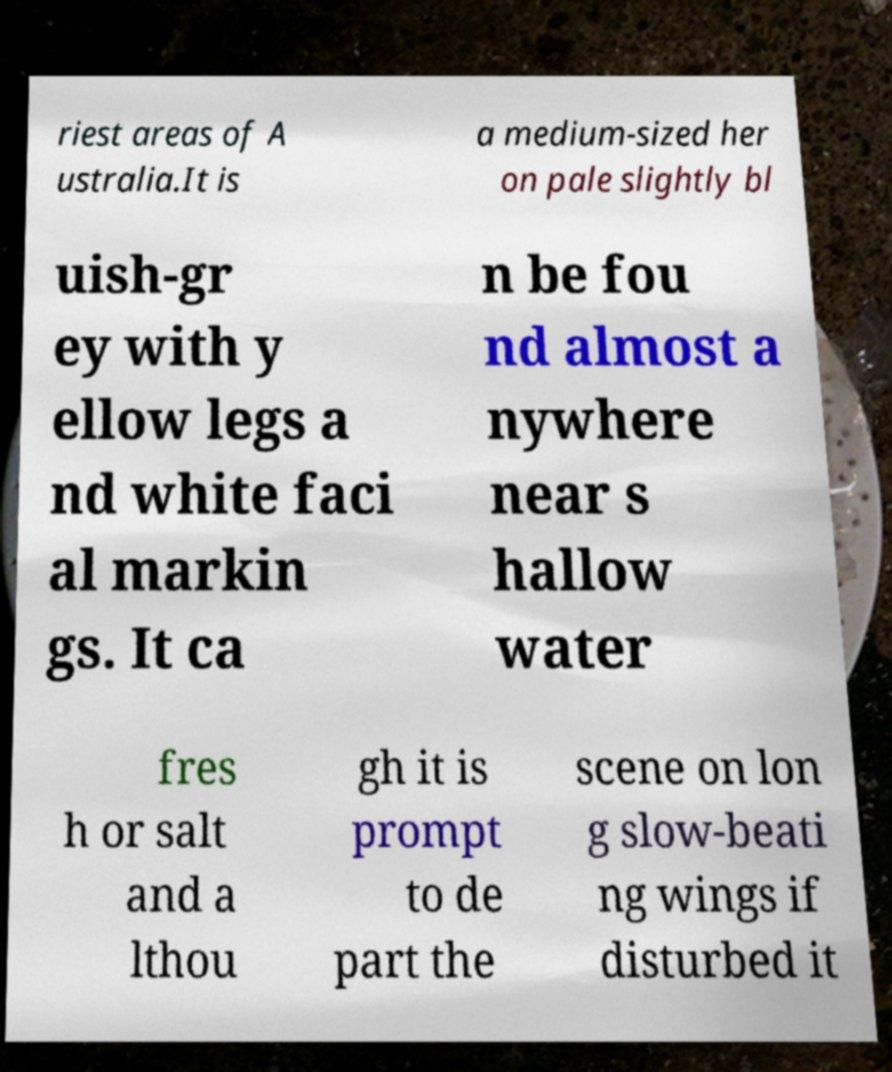There's text embedded in this image that I need extracted. Can you transcribe it verbatim? riest areas of A ustralia.It is a medium-sized her on pale slightly bl uish-gr ey with y ellow legs a nd white faci al markin gs. It ca n be fou nd almost a nywhere near s hallow water fres h or salt and a lthou gh it is prompt to de part the scene on lon g slow-beati ng wings if disturbed it 